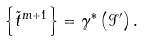<formula> <loc_0><loc_0><loc_500><loc_500>\left \{ \tilde { t } ^ { m + 1 } \right \} = \gamma ^ { * } \left ( \mathcal { I } ^ { \prime } \right ) .</formula> 